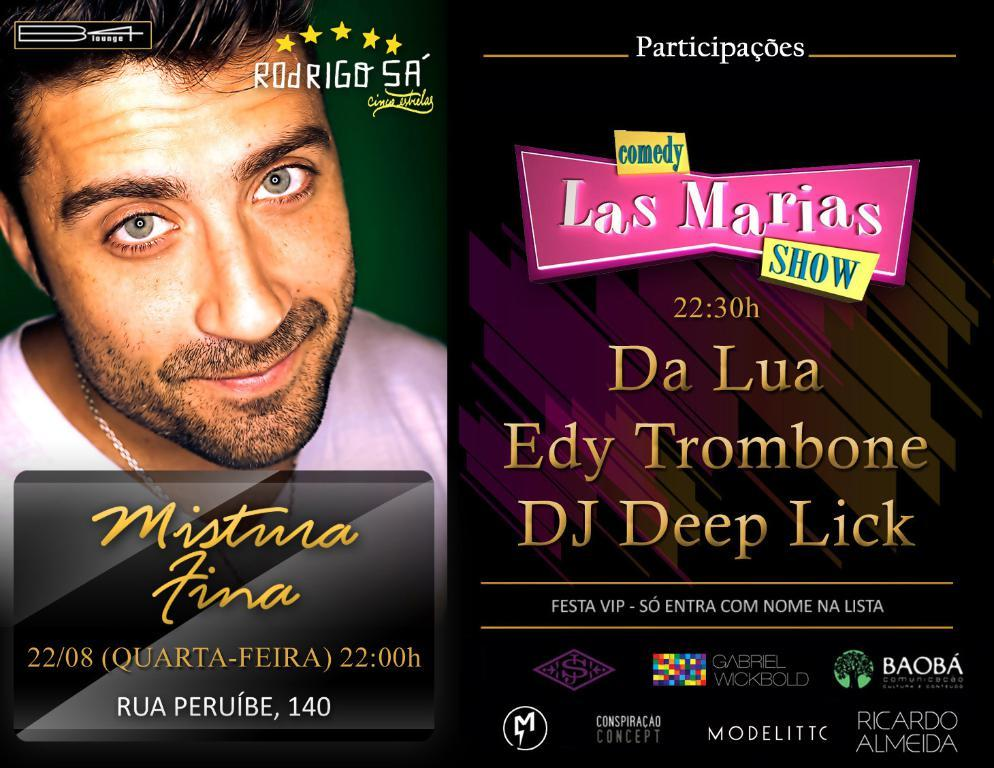What is present in the image that contains visual and written information? There is a poster in the image that contains images and text. Can you describe the images on the poster? The provided facts do not specify the images on the poster, so we cannot describe them. What type of information is conveyed through the text on the poster? The provided facts do not specify the content of the text on the poster, so we cannot describe the information conveyed. What color is the twig that is hanging from the underwear in the image? There is no underwear or twig present in the image; it only contains a poster with images and text. 